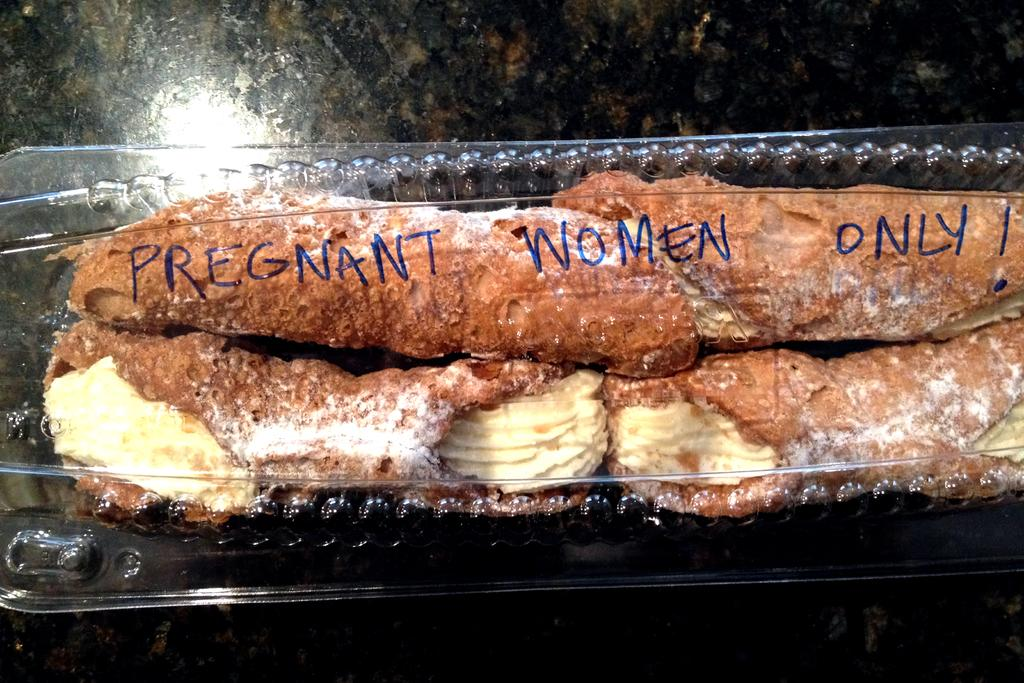What type of food can be seen in the image? The food in the image has brown and yellow colors. Can you describe any specific details about the food? The food has text written on it or its packaging. What is the color of the background in the image? The background of the image is dark. What type of design can be seen on the thing in the image? There is no "thing" mentioned in the facts, and the image only contains food with text on it or its packaging. 